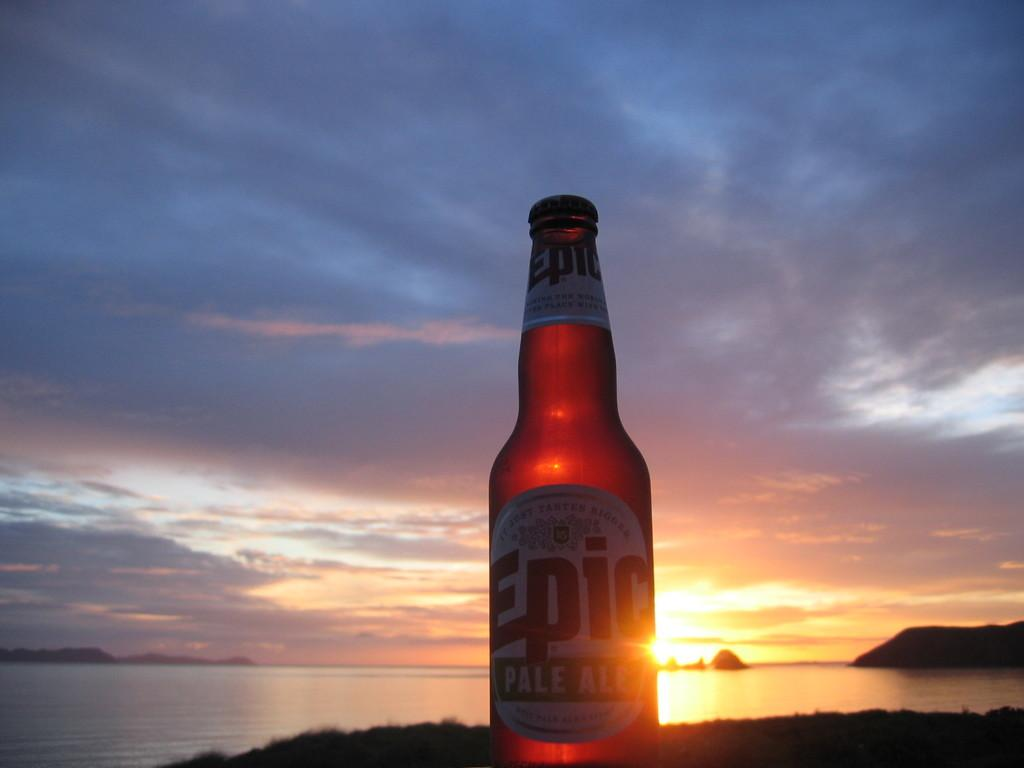<image>
Offer a succinct explanation of the picture presented. Bottle of Epic Pale Ale sitting in front of the sunset 